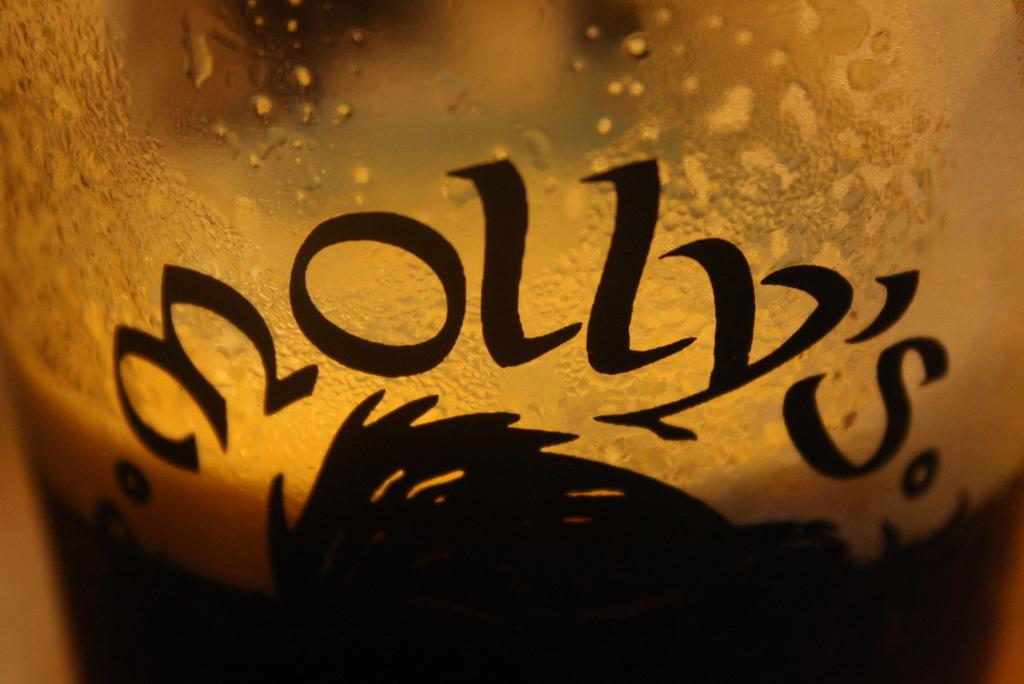<image>
Give a short and clear explanation of the subsequent image. A glass that says Molly's is filled with liquid. 